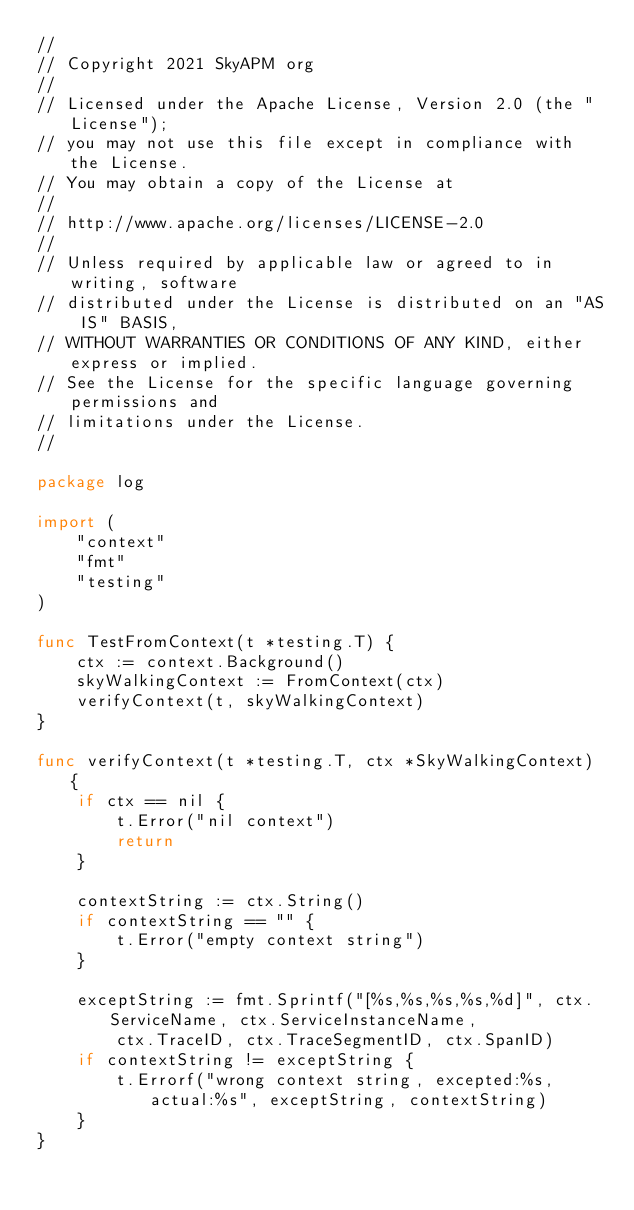Convert code to text. <code><loc_0><loc_0><loc_500><loc_500><_Go_>//
// Copyright 2021 SkyAPM org
//
// Licensed under the Apache License, Version 2.0 (the "License");
// you may not use this file except in compliance with the License.
// You may obtain a copy of the License at
//
// http://www.apache.org/licenses/LICENSE-2.0
//
// Unless required by applicable law or agreed to in writing, software
// distributed under the License is distributed on an "AS IS" BASIS,
// WITHOUT WARRANTIES OR CONDITIONS OF ANY KIND, either express or implied.
// See the License for the specific language governing permissions and
// limitations under the License.
//

package log

import (
	"context"
	"fmt"
	"testing"
)

func TestFromContext(t *testing.T) {
	ctx := context.Background()
	skyWalkingContext := FromContext(ctx)
	verifyContext(t, skyWalkingContext)
}

func verifyContext(t *testing.T, ctx *SkyWalkingContext) {
	if ctx == nil {
		t.Error("nil context")
		return
	}

	contextString := ctx.String()
	if contextString == "" {
		t.Error("empty context string")
	}

	exceptString := fmt.Sprintf("[%s,%s,%s,%s,%d]", ctx.ServiceName, ctx.ServiceInstanceName,
		ctx.TraceID, ctx.TraceSegmentID, ctx.SpanID)
	if contextString != exceptString {
		t.Errorf("wrong context string, excepted:%s, actual:%s", exceptString, contextString)
	}
}
</code> 